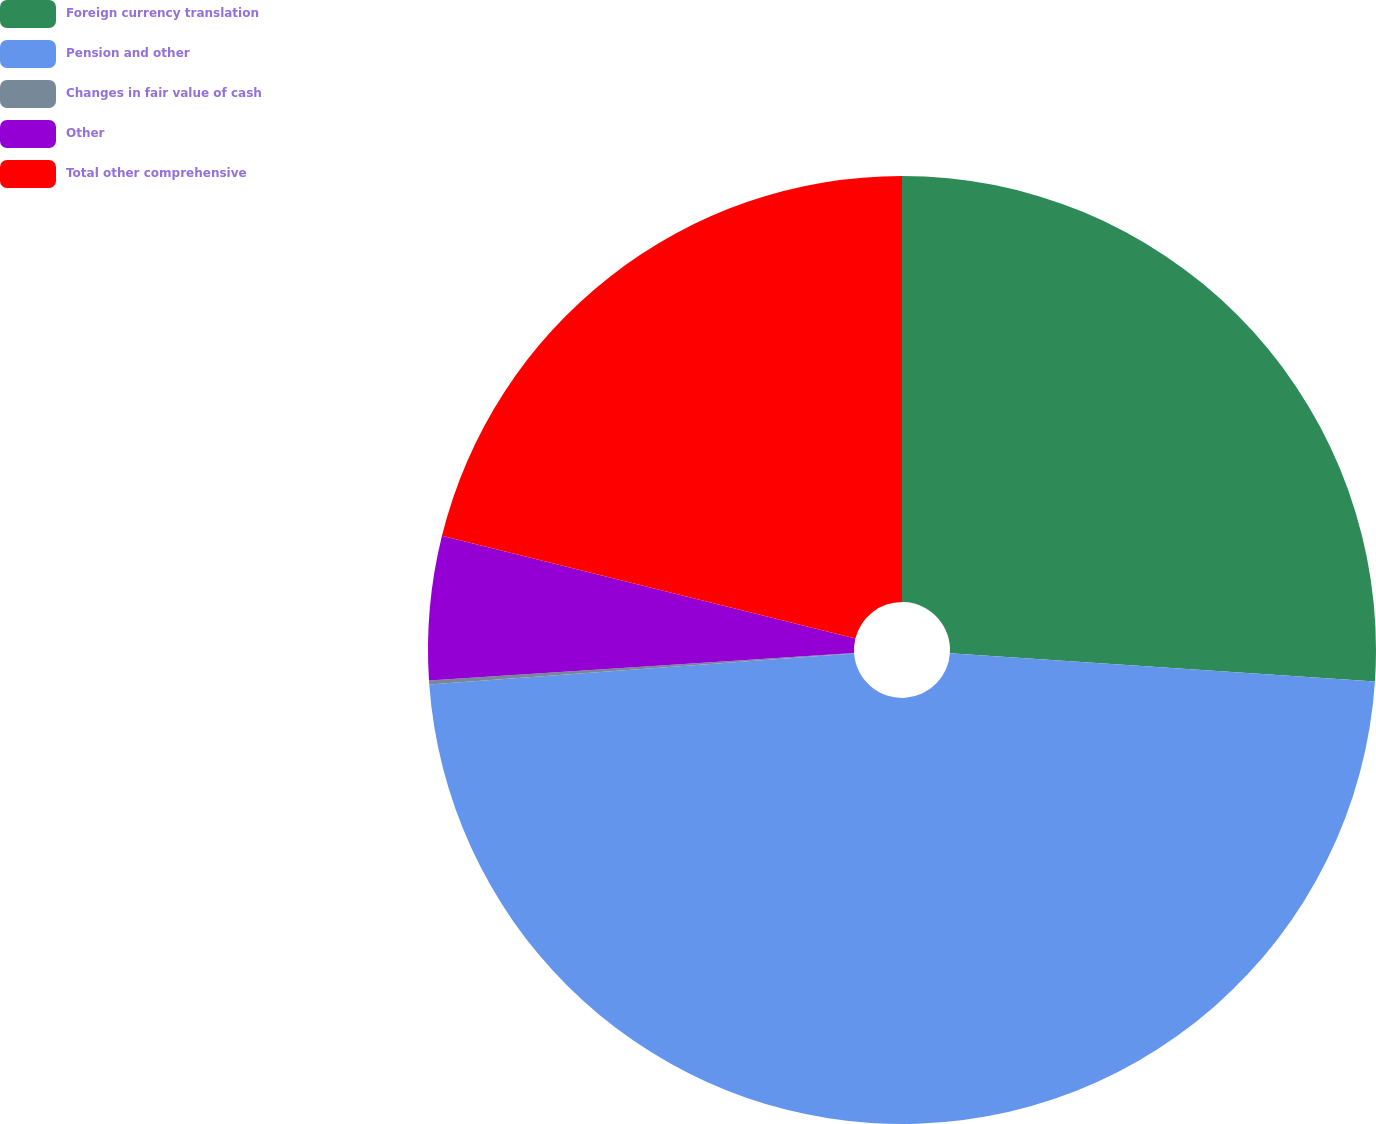<chart> <loc_0><loc_0><loc_500><loc_500><pie_chart><fcel>Foreign currency translation<fcel>Pension and other<fcel>Changes in fair value of cash<fcel>Other<fcel>Total other comprehensive<nl><fcel>26.06%<fcel>47.79%<fcel>0.13%<fcel>4.9%<fcel>21.13%<nl></chart> 